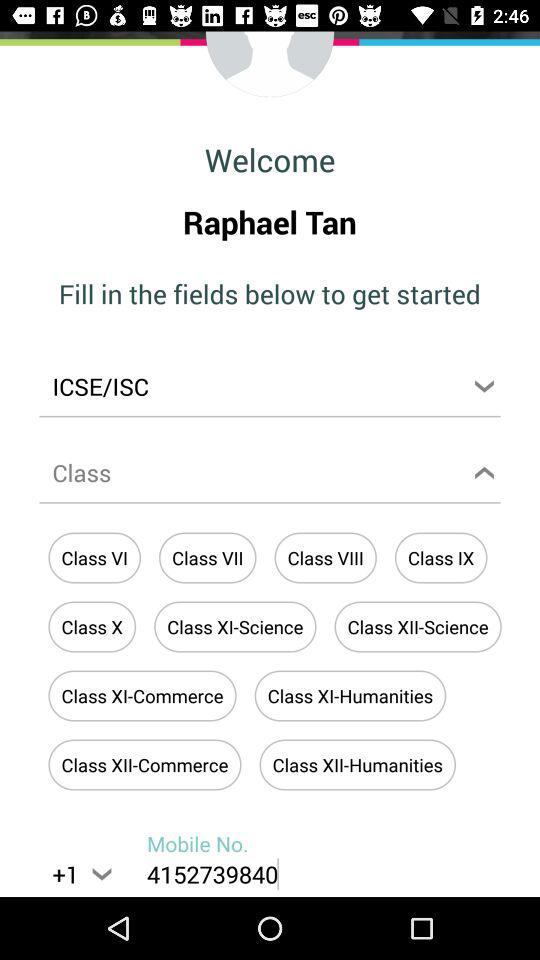What is the mobile number? The mobile number is +14152739840. 